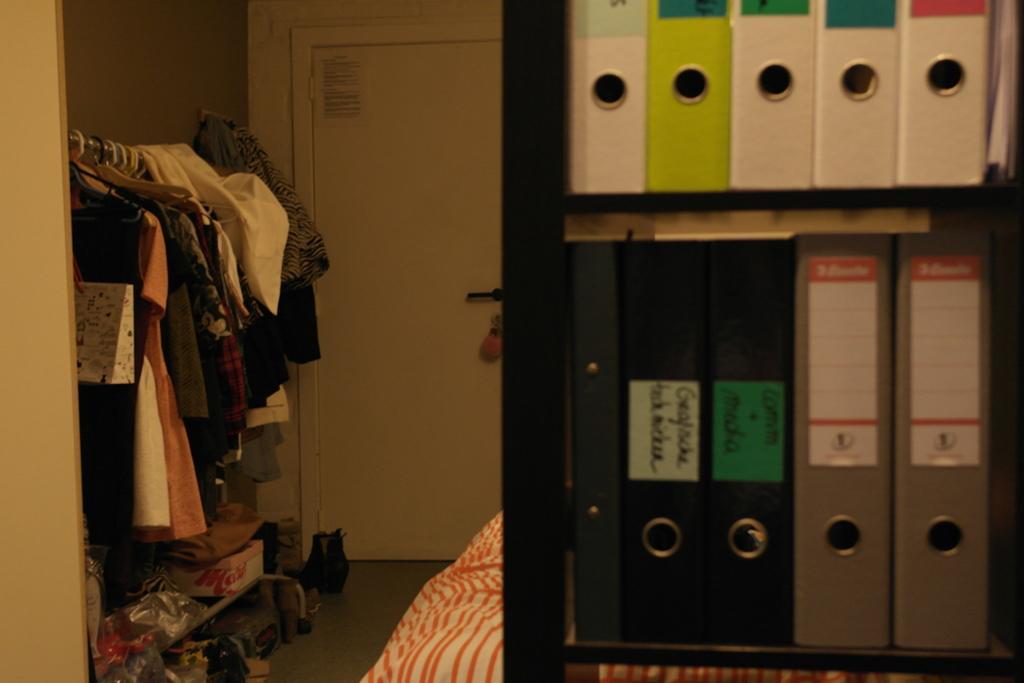Could you give a brief overview of what you see in this image? This is an inside view. On the right side there are few boxes in the rack, behind there is a bed. On the left side there are few clothes hanging to a metal rod. In the background there is a door to the wall. 